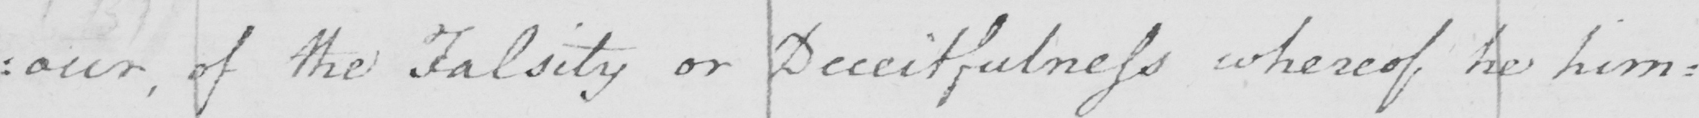Transcribe the text shown in this historical manuscript line. : our , of the Falsity or Deceitfulness whereof he him : 